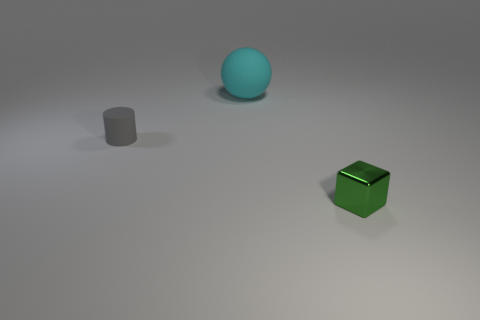The big object has what shape?
Your answer should be very brief. Sphere. Is the number of cylinders that are left of the gray rubber cylinder greater than the number of tiny cylinders on the right side of the tiny green metallic block?
Provide a short and direct response. No. How many other things are the same size as the cyan matte ball?
Provide a succinct answer. 0. There is a thing that is on the right side of the tiny gray rubber thing and in front of the cyan sphere; what material is it made of?
Your answer should be very brief. Metal. There is a small thing that is to the left of the big cyan thing that is on the right side of the small cylinder; how many small metal things are in front of it?
Your response must be concise. 1. Is there anything else that has the same color as the tiny metal thing?
Offer a terse response. No. What number of rubber things are both behind the tiny rubber cylinder and on the left side of the big cyan object?
Offer a very short reply. 0. There is a matte object that is in front of the cyan matte sphere; does it have the same size as the thing that is right of the big sphere?
Offer a terse response. Yes. What number of objects are either tiny objects that are on the left side of the cyan ball or big rubber spheres?
Offer a terse response. 2. There is a cube that is to the right of the cylinder; what material is it?
Provide a short and direct response. Metal. 